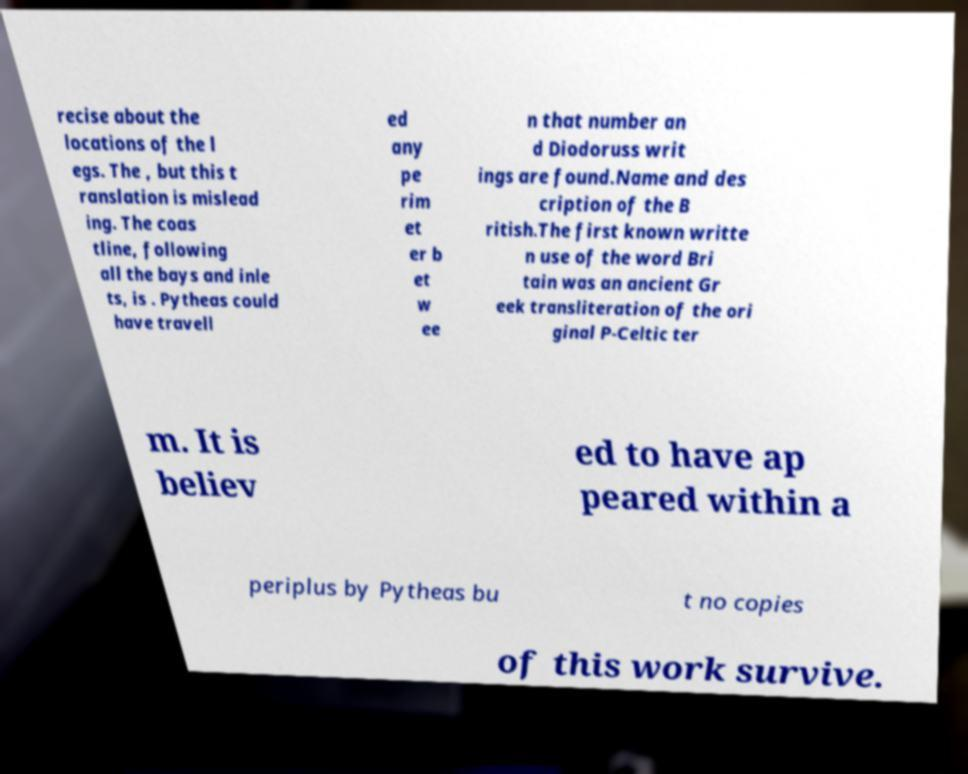Please read and relay the text visible in this image. What does it say? recise about the locations of the l egs. The , but this t ranslation is mislead ing. The coas tline, following all the bays and inle ts, is . Pytheas could have travell ed any pe rim et er b et w ee n that number an d Diodoruss writ ings are found.Name and des cription of the B ritish.The first known writte n use of the word Bri tain was an ancient Gr eek transliteration of the ori ginal P-Celtic ter m. It is believ ed to have ap peared within a periplus by Pytheas bu t no copies of this work survive. 